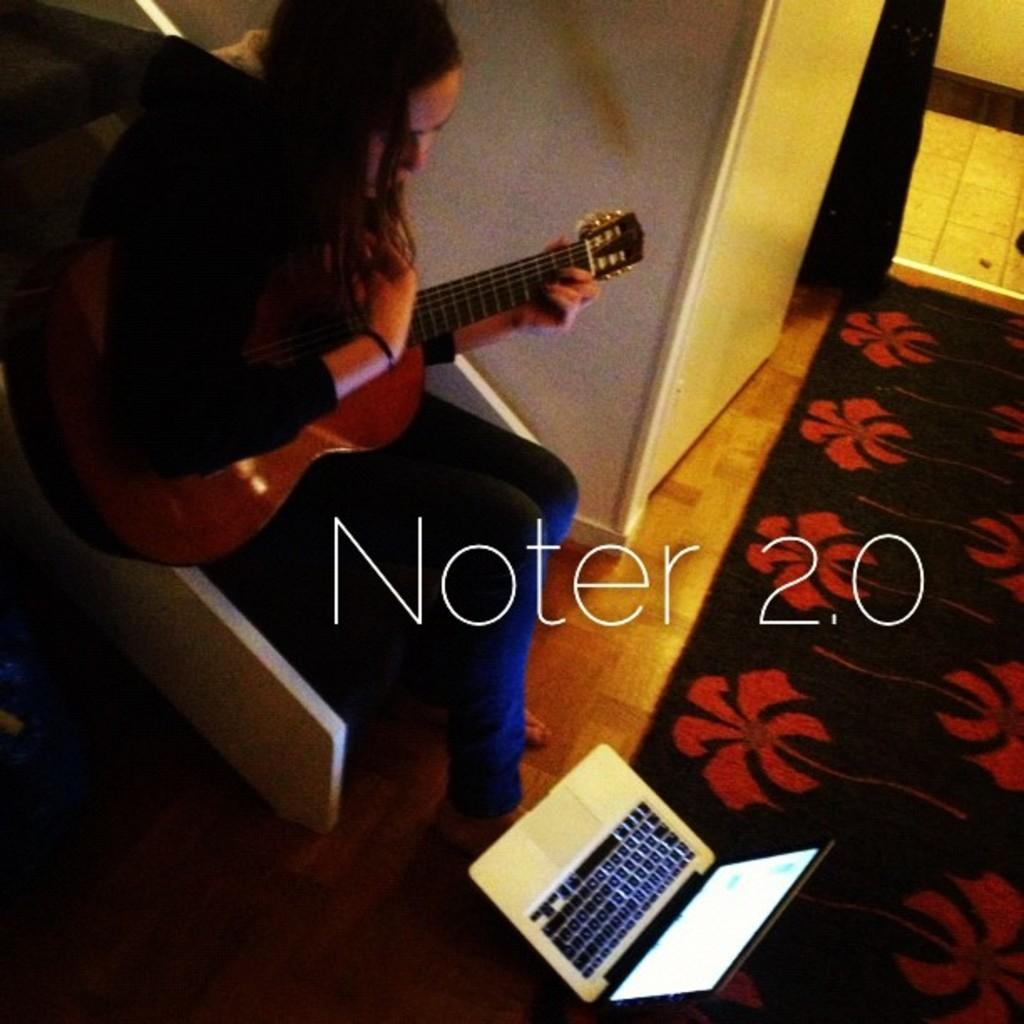Who is the main subject in the image? There is a woman in the image. What is the woman doing in the image? The woman is sitting on a chair and holding a guitar. What is the woman looking at in the image? The woman is looking at a laptop. Where is the laptop located in the image? The laptop is on the floor. What color is the heart-shaped dust on the guitar in the image? There is no heart-shaped dust present in the image. 